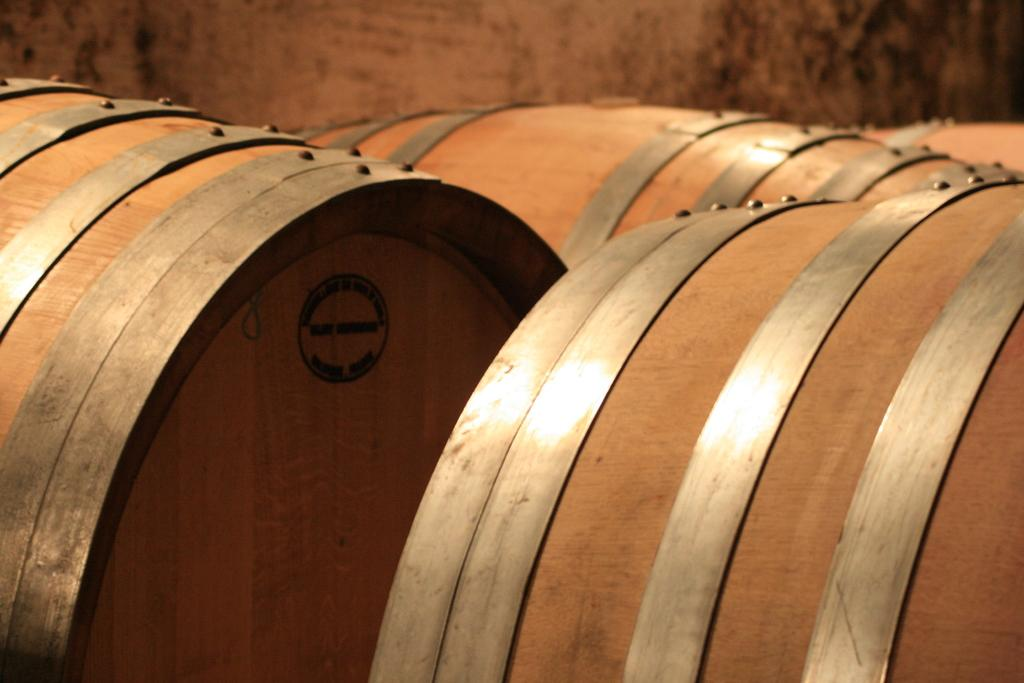What type of containers are present in the image? There are wooden barrels in the image. What can be seen in the background of the image? There is a wall in the background of the image. What type of leather is being used to make the instrument in the image? There is no instrument present in the image, so it is not possible to determine what type of leather might be used. 